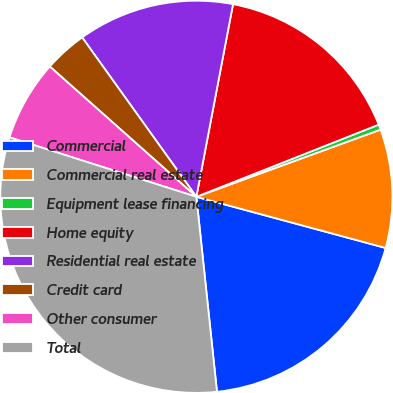Convert chart to OTSL. <chart><loc_0><loc_0><loc_500><loc_500><pie_chart><fcel>Commercial<fcel>Commercial real estate<fcel>Equipment lease financing<fcel>Home equity<fcel>Residential real estate<fcel>Credit card<fcel>Other consumer<fcel>Total<nl><fcel>19.12%<fcel>9.77%<fcel>0.43%<fcel>16.01%<fcel>12.89%<fcel>3.54%<fcel>6.66%<fcel>31.58%<nl></chart> 